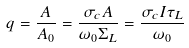Convert formula to latex. <formula><loc_0><loc_0><loc_500><loc_500>q = \frac { A } { A _ { 0 } } = \frac { \sigma _ { c } A } { \omega _ { 0 } \Sigma _ { L } } = \frac { \sigma _ { c } I \tau _ { L } } { \omega _ { 0 } }</formula> 